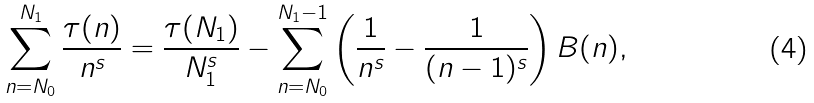<formula> <loc_0><loc_0><loc_500><loc_500>\sum _ { n = N _ { 0 } } ^ { N _ { 1 } } \frac { \tau ( n ) } { n ^ { s } } = \frac { \tau ( N _ { 1 } ) } { N _ { 1 } ^ { s } } - \sum _ { n = N _ { 0 } } ^ { N _ { 1 } - 1 } \left ( \frac { 1 } { n ^ { s } } - \frac { 1 } { ( n - 1 ) ^ { s } } \right ) B ( n ) ,</formula> 